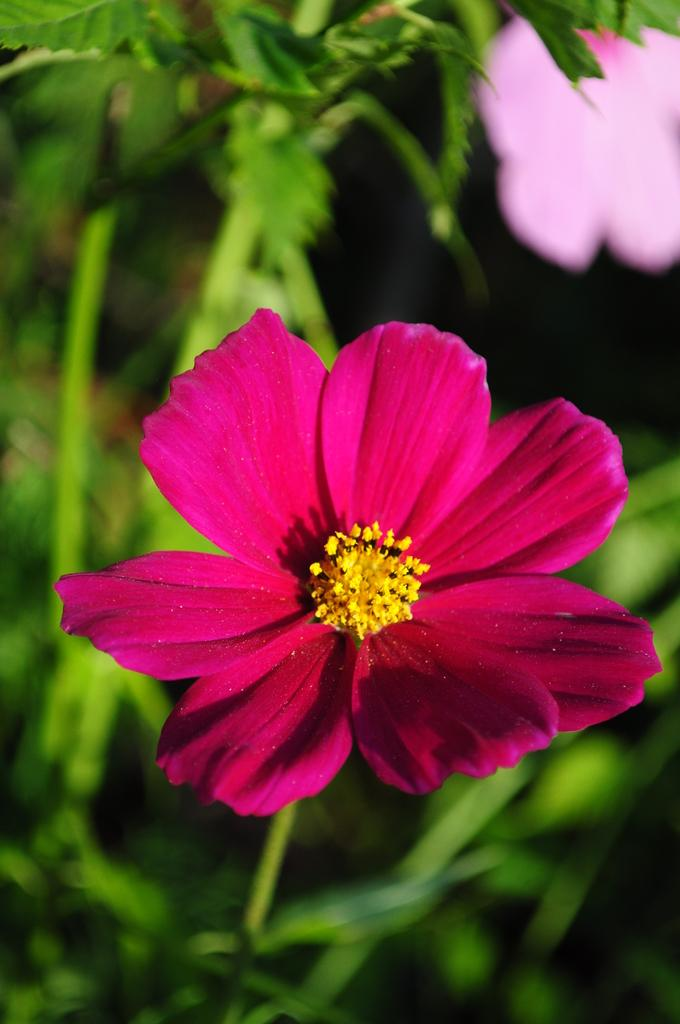What type of plant is depicted in the image? There is a flower in the image, along with leaves and stems. What colors can be seen in the plant elements of the image? The flower, leaves, and stems are not explicitly described in terms of color, but the pink color object in the top right corner suggests that the plant may have some pink elements. Can you describe the overall composition of the image? The image primarily features a flower, leaves, and stems, with a pink color object in the top right corner. Can you tell me how many seashores are visible in the image? There are no seashores visible in the image; it primarily features a flower, leaves, stems, and a pink color object. What type of liquid is being poured from the button in the image? There is no button or liquid present in the image. 